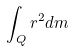Convert formula to latex. <formula><loc_0><loc_0><loc_500><loc_500>\int _ { Q } r ^ { 2 } d m</formula> 